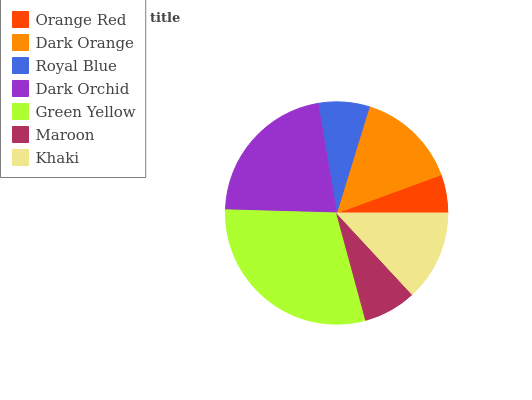Is Orange Red the minimum?
Answer yes or no. Yes. Is Green Yellow the maximum?
Answer yes or no. Yes. Is Dark Orange the minimum?
Answer yes or no. No. Is Dark Orange the maximum?
Answer yes or no. No. Is Dark Orange greater than Orange Red?
Answer yes or no. Yes. Is Orange Red less than Dark Orange?
Answer yes or no. Yes. Is Orange Red greater than Dark Orange?
Answer yes or no. No. Is Dark Orange less than Orange Red?
Answer yes or no. No. Is Khaki the high median?
Answer yes or no. Yes. Is Khaki the low median?
Answer yes or no. Yes. Is Maroon the high median?
Answer yes or no. No. Is Green Yellow the low median?
Answer yes or no. No. 